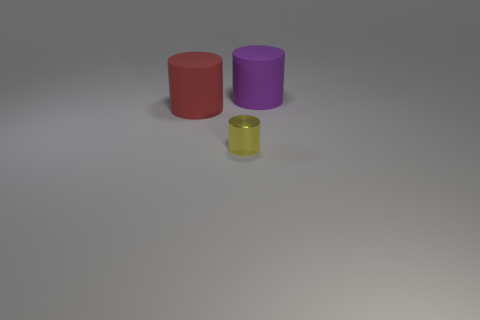Is there any other thing that is the same shape as the tiny yellow object?
Your answer should be very brief. Yes. What color is the tiny metallic object that is the same shape as the large purple matte object?
Your response must be concise. Yellow. The other large object that is made of the same material as the purple thing is what color?
Make the answer very short. Red. Are there an equal number of metal things behind the purple matte cylinder and tiny green spheres?
Give a very brief answer. Yes. Does the rubber cylinder that is left of the yellow cylinder have the same size as the purple rubber thing?
Keep it short and to the point. Yes. There is a thing that is the same size as the red rubber cylinder; what color is it?
Offer a very short reply. Purple. Is there a tiny yellow cylinder that is left of the thing to the left of the small metallic object to the right of the red cylinder?
Your response must be concise. No. There is a yellow object in front of the red thing; what is it made of?
Your answer should be very brief. Metal. Are there an equal number of metallic cylinders to the right of the purple rubber cylinder and large purple rubber cylinders behind the red matte cylinder?
Make the answer very short. No. What number of other things are the same material as the small thing?
Offer a very short reply. 0. 